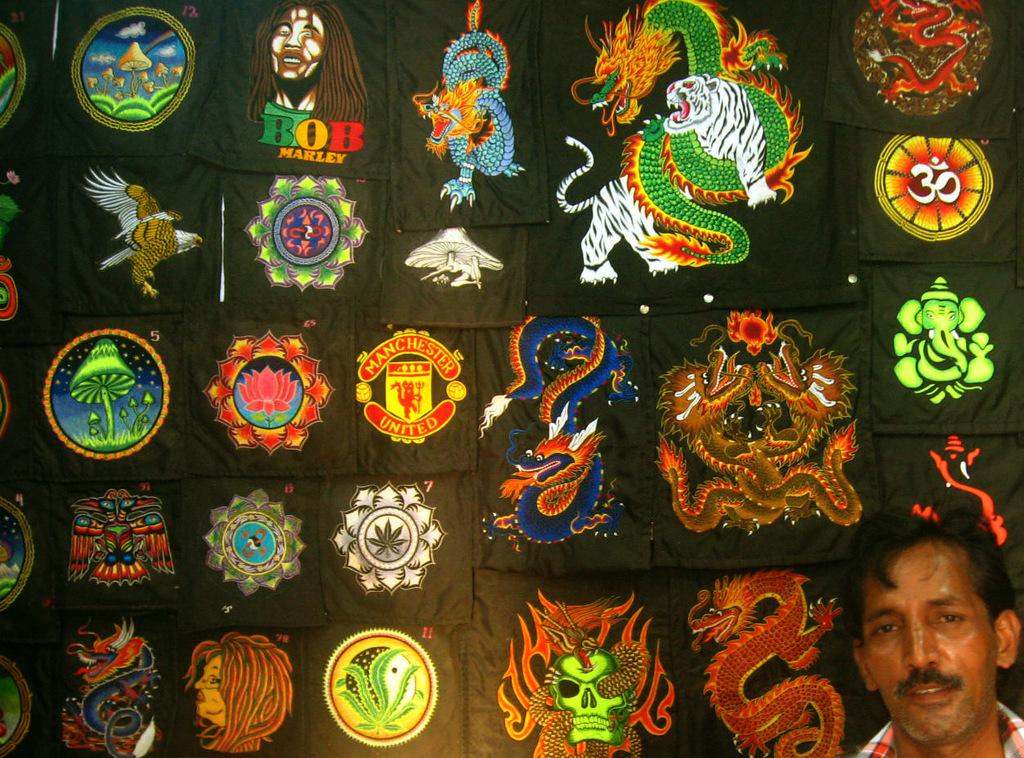Where is the person located in the image? The person is in the bottom right of the image. What is the background color of the images in the picture? The images are on a black surface. What types of images can be seen on the black surface? There are images of animals, people, flowers, plants, logos, symbols, gods, and other images on the black surface. How many eggs are being transported by the trucks in the image? There are no trucks or eggs present in the image. What type of experience can be gained from the images in the picture? The images in the picture are static and do not provide an experience. 